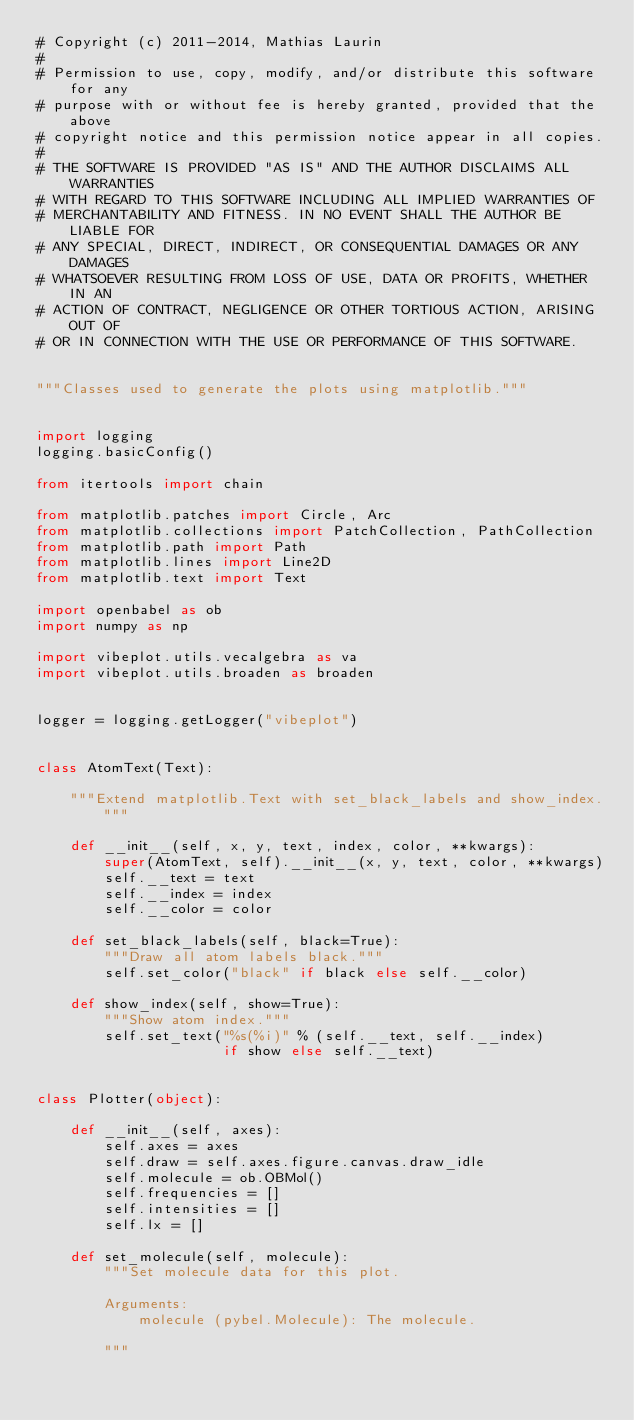Convert code to text. <code><loc_0><loc_0><loc_500><loc_500><_Python_># Copyright (c) 2011-2014, Mathias Laurin
#
# Permission to use, copy, modify, and/or distribute this software for any
# purpose with or without fee is hereby granted, provided that the above
# copyright notice and this permission notice appear in all copies.
#
# THE SOFTWARE IS PROVIDED "AS IS" AND THE AUTHOR DISCLAIMS ALL WARRANTIES
# WITH REGARD TO THIS SOFTWARE INCLUDING ALL IMPLIED WARRANTIES OF
# MERCHANTABILITY AND FITNESS. IN NO EVENT SHALL THE AUTHOR BE LIABLE FOR
# ANY SPECIAL, DIRECT, INDIRECT, OR CONSEQUENTIAL DAMAGES OR ANY DAMAGES
# WHATSOEVER RESULTING FROM LOSS OF USE, DATA OR PROFITS, WHETHER IN AN
# ACTION OF CONTRACT, NEGLIGENCE OR OTHER TORTIOUS ACTION, ARISING OUT OF
# OR IN CONNECTION WITH THE USE OR PERFORMANCE OF THIS SOFTWARE.


"""Classes used to generate the plots using matplotlib."""


import logging
logging.basicConfig()

from itertools import chain

from matplotlib.patches import Circle, Arc
from matplotlib.collections import PatchCollection, PathCollection
from matplotlib.path import Path
from matplotlib.lines import Line2D
from matplotlib.text import Text

import openbabel as ob
import numpy as np

import vibeplot.utils.vecalgebra as va
import vibeplot.utils.broaden as broaden


logger = logging.getLogger("vibeplot")


class AtomText(Text):

    """Extend matplotlib.Text with set_black_labels and show_index."""

    def __init__(self, x, y, text, index, color, **kwargs):
        super(AtomText, self).__init__(x, y, text, color, **kwargs)
        self.__text = text
        self.__index = index
        self.__color = color

    def set_black_labels(self, black=True):
        """Draw all atom labels black."""
        self.set_color("black" if black else self.__color)

    def show_index(self, show=True):
        """Show atom index."""
        self.set_text("%s(%i)" % (self.__text, self.__index)
                      if show else self.__text)


class Plotter(object):

    def __init__(self, axes):
        self.axes = axes
        self.draw = self.axes.figure.canvas.draw_idle
        self.molecule = ob.OBMol()
        self.frequencies = []
        self.intensities = []
        self.lx = []

    def set_molecule(self, molecule):
        """Set molecule data for this plot.

        Arguments:
            molecule (pybel.Molecule): The molecule.

        """</code> 